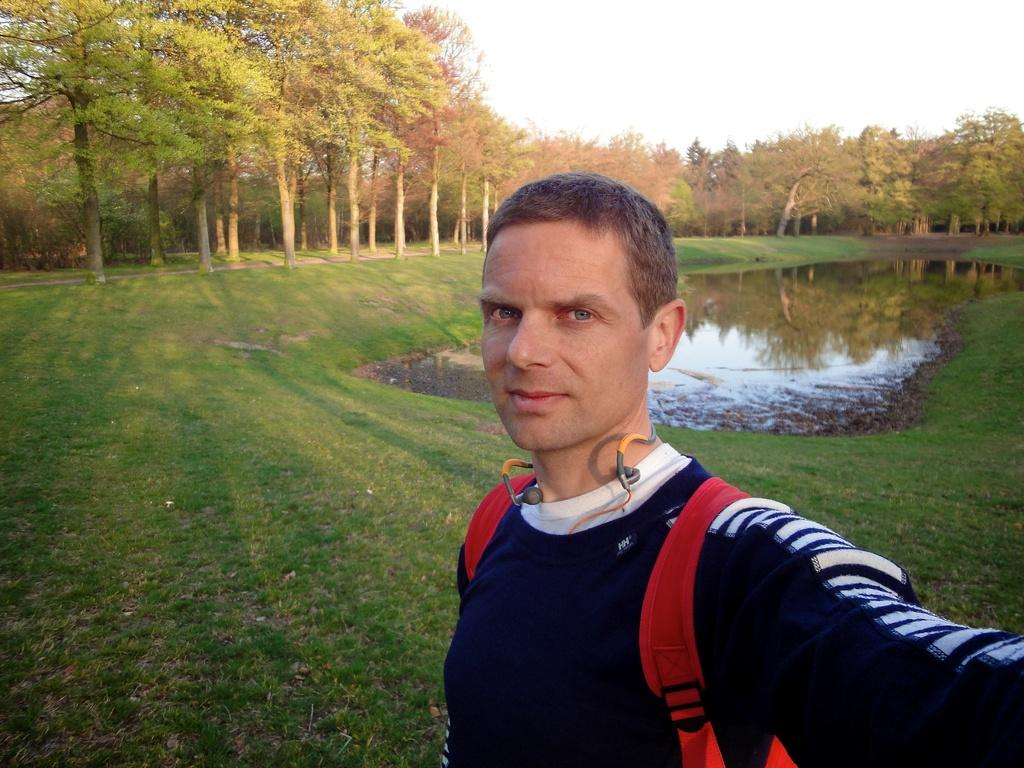What is the main subject of the image? There is a person in the image. What is the person wearing on their back? The person is wearing a red backpack. What is the person's facial expression? The person is smiling. What type of natural environment is visible in the background of the image? There is grass, water, and trees visible in the background of the image. What part of the sky is visible in the image? The sky is visible at the top of the image. How many women are expanding their wrists in the image? There are no women or wrist expansion activities present in the image. 